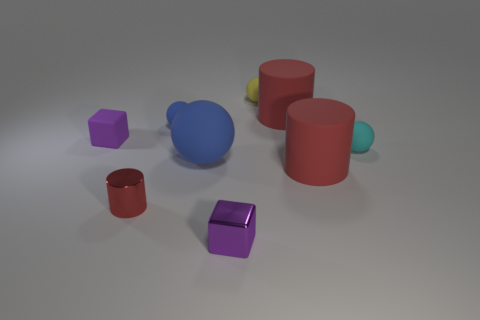The large blue object has what shape?
Offer a very short reply. Sphere. Is the number of cyan matte spheres behind the small purple rubber object greater than the number of things on the right side of the small cyan sphere?
Ensure brevity in your answer.  No. How many other things are the same size as the cyan matte ball?
Your answer should be very brief. 5. There is a thing that is both behind the red metallic cylinder and to the left of the tiny blue object; what is its material?
Offer a very short reply. Rubber. What material is the large thing that is the same shape as the tiny yellow rubber thing?
Your answer should be compact. Rubber. There is a red rubber object in front of the blue rubber sphere in front of the cyan ball; how many purple cubes are in front of it?
Your response must be concise. 1. Is there anything else that has the same color as the tiny rubber block?
Your response must be concise. Yes. How many shiny objects are both left of the small blue rubber object and on the right side of the small red shiny thing?
Provide a short and direct response. 0. Is the size of the block on the left side of the shiny block the same as the red cylinder left of the tiny blue thing?
Keep it short and to the point. Yes. How many things are big red rubber objects behind the small rubber block or large brown blocks?
Your response must be concise. 1. 